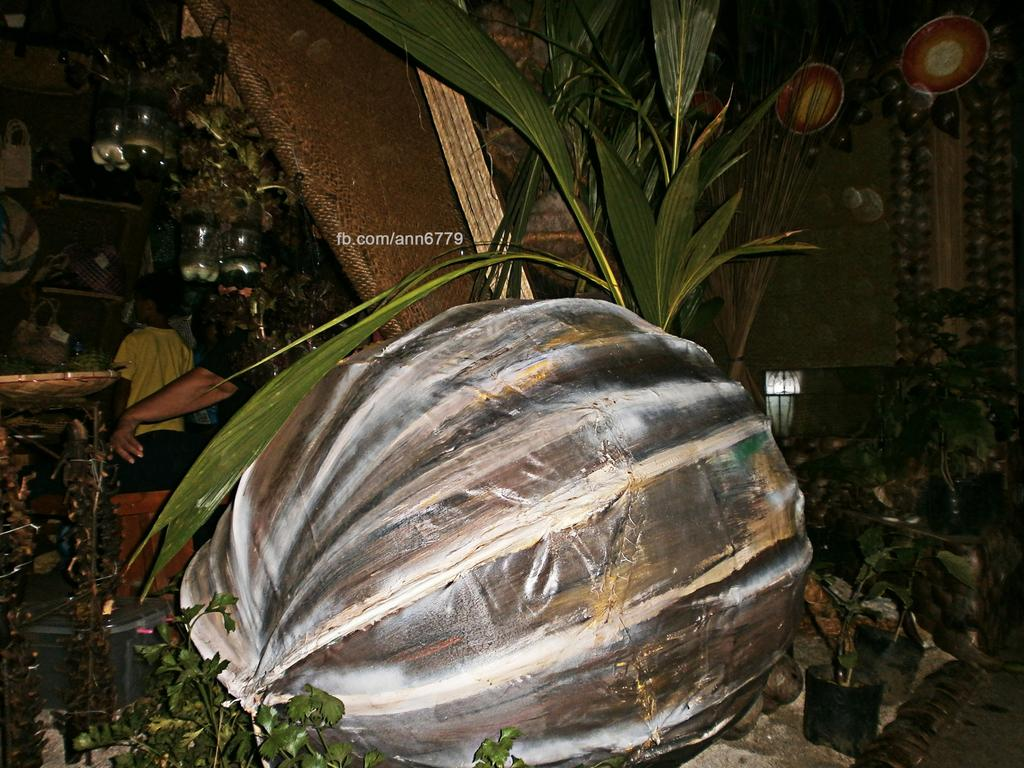What is located in the foreground of the image? There is an object and plants in the foreground of the image. Can you describe the plants in the foreground? The plants in the foreground are hanging from bottles. What can be seen in the background of the image? There are people visible in the background of the image. How many knives are hanging from the plants in the image? There are no knives present in the image; it features plants hanging from bottles. What type of wire is used to hang the fifth plant in the image? There is no fifth plant in the image, and no wire is mentioned in the provided facts. 